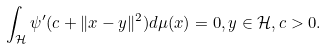<formula> <loc_0><loc_0><loc_500><loc_500>\int _ { \mathcal { H } } \psi ^ { \prime } ( c + \| x - y \| ^ { 2 } ) d \mu ( x ) = 0 , y \in \mathcal { H } , c > 0 .</formula> 